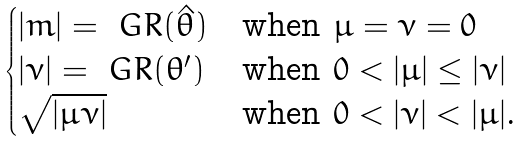Convert formula to latex. <formula><loc_0><loc_0><loc_500><loc_500>\begin{cases} | m | = \ G R ( \hat { \theta } ) & \text {when $\mu=\nu=0$} \\ | \nu | = \ G R ( \theta ^ { \prime } ) & \text {when $0<|\mu|\leq|\nu|$} \\ \sqrt { | \mu \nu | } & \text {when $0<|\nu|<|\mu|$.} \end{cases}</formula> 